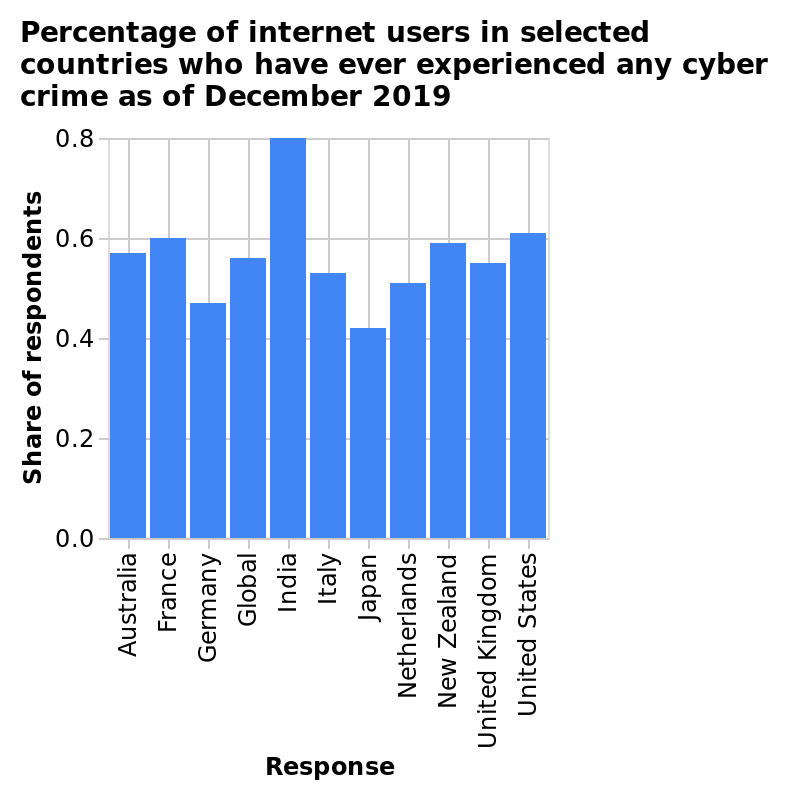<image>
Which country's data is plotted first on the x-axis? Australia's data is plotted first on the x-axis. Which countries had a share greater than 0.6 of respondents who experienced any kind of cyber crime?  The United States and India. Which country has a higher number of fair trade workers, India or Columbia? India 